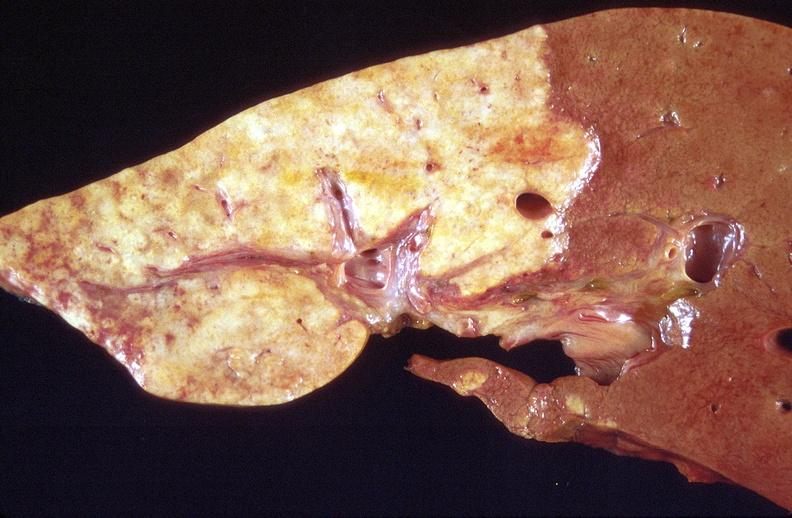what does this image show?
Answer the question using a single word or phrase. Cholangiocarcinoma 